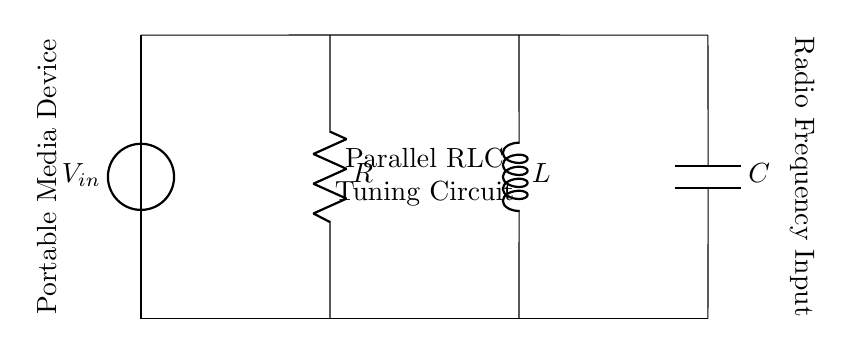What type of circuit is shown? The circuit is a parallel RLC tuning circuit, which includes a resistor, inductor, and capacitor connected in parallel to tune radio frequencies.
Answer: Parallel RLC circuit What is the component connected to the left of the circuit? The component on the left is a voltage source labeled as V_in, providing input voltage to the circuit.
Answer: Voltage source How many components are present in the circuit? There are three main components in this circuit: a resistor, an inductor, and a capacitor.
Answer: Three What is the purpose of this circuit? The purpose of the circuit is to tune radio frequencies in portable media devices, facilitating reception of specific radio signals.
Answer: Tune radio frequencies Which component is used to store energy in the circuit? The capacitor is used to store electrical energy in the circuit, allowing it to smooth out voltage variations and filter frequencies.
Answer: Capacitor What happens to the circuit's impedance at resonance? At resonance, the impedance of the parallel RLC circuit reaches its minimum value, allowing maximum current to flow through the circuit.
Answer: Minimum How would you describe the connections of the components? The components are connected in parallel, meaning all components share the same two nodes and thus have the same voltage across them.
Answer: In parallel 